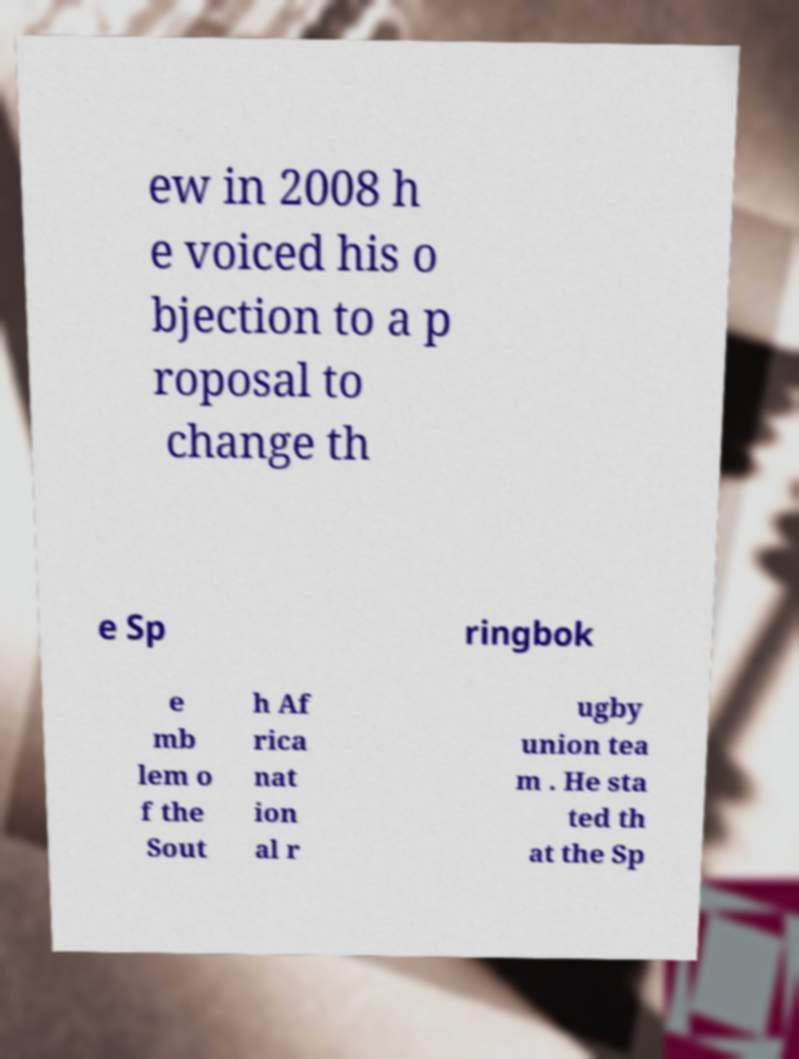Could you extract and type out the text from this image? ew in 2008 h e voiced his o bjection to a p roposal to change th e Sp ringbok e mb lem o f the Sout h Af rica nat ion al r ugby union tea m . He sta ted th at the Sp 